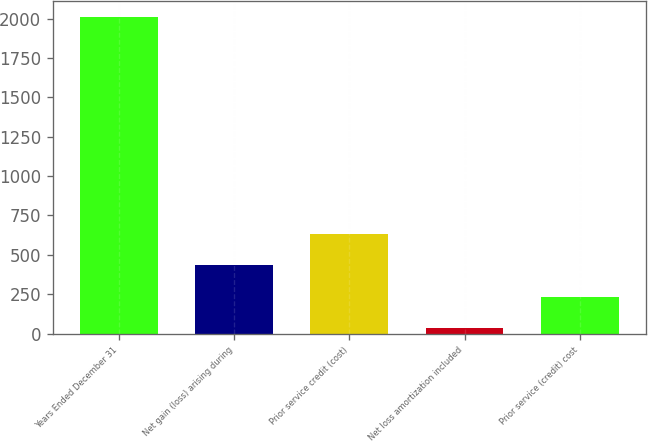Convert chart to OTSL. <chart><loc_0><loc_0><loc_500><loc_500><bar_chart><fcel>Years Ended December 31<fcel>Net gain (loss) arising during<fcel>Prior service credit (cost)<fcel>Net loss amortization included<fcel>Prior service (credit) cost<nl><fcel>2011<fcel>432.6<fcel>629.9<fcel>38<fcel>235.3<nl></chart> 